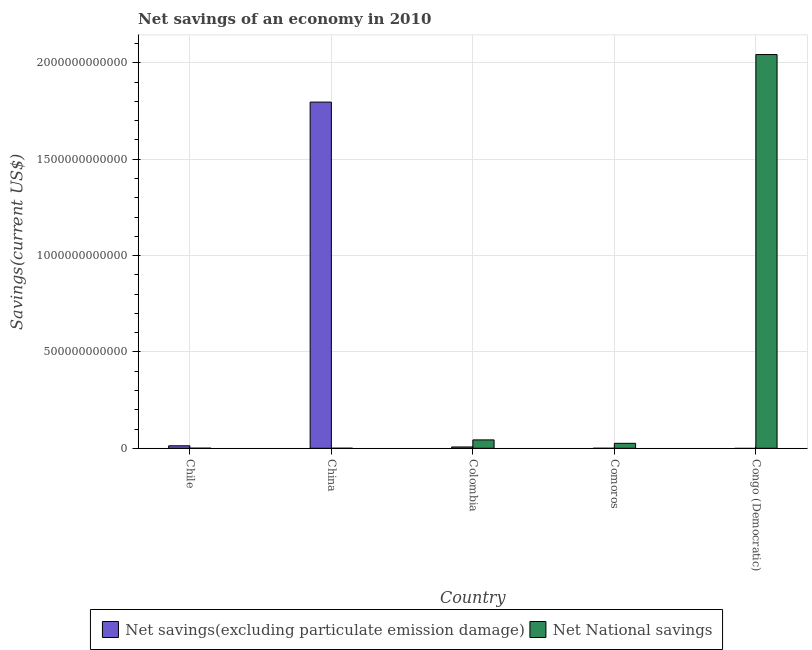How many different coloured bars are there?
Offer a terse response. 2. Are the number of bars per tick equal to the number of legend labels?
Your answer should be compact. No. Are the number of bars on each tick of the X-axis equal?
Provide a short and direct response. No. How many bars are there on the 5th tick from the left?
Your answer should be very brief. 1. How many bars are there on the 5th tick from the right?
Your answer should be very brief. 2. What is the net national savings in Colombia?
Keep it short and to the point. 4.35e+1. Across all countries, what is the maximum net savings(excluding particulate emission damage)?
Your response must be concise. 1.80e+12. Across all countries, what is the minimum net national savings?
Offer a terse response. 1.62e+08. In which country was the net savings(excluding particulate emission damage) maximum?
Your answer should be compact. China. What is the total net savings(excluding particulate emission damage) in the graph?
Your answer should be very brief. 1.82e+12. What is the difference between the net savings(excluding particulate emission damage) in Chile and that in China?
Your answer should be very brief. -1.78e+12. What is the difference between the net national savings in China and the net savings(excluding particulate emission damage) in Chile?
Provide a short and direct response. -1.27e+1. What is the average net savings(excluding particulate emission damage) per country?
Make the answer very short. 3.63e+11. What is the difference between the net national savings and net savings(excluding particulate emission damage) in Chile?
Make the answer very short. -1.26e+1. What is the ratio of the net national savings in Comoros to that in Congo (Democratic)?
Keep it short and to the point. 0.01. What is the difference between the highest and the second highest net national savings?
Make the answer very short. 2.00e+12. What is the difference between the highest and the lowest net national savings?
Provide a succinct answer. 2.04e+12. In how many countries, is the net savings(excluding particulate emission damage) greater than the average net savings(excluding particulate emission damage) taken over all countries?
Your answer should be very brief. 1. Are all the bars in the graph horizontal?
Offer a very short reply. No. How many countries are there in the graph?
Your response must be concise. 5. What is the difference between two consecutive major ticks on the Y-axis?
Give a very brief answer. 5.00e+11. Does the graph contain any zero values?
Offer a very short reply. Yes. Does the graph contain grids?
Ensure brevity in your answer.  Yes. How many legend labels are there?
Give a very brief answer. 2. How are the legend labels stacked?
Your response must be concise. Horizontal. What is the title of the graph?
Your response must be concise. Net savings of an economy in 2010. Does "Merchandise exports" appear as one of the legend labels in the graph?
Give a very brief answer. No. What is the label or title of the X-axis?
Your response must be concise. Country. What is the label or title of the Y-axis?
Your response must be concise. Savings(current US$). What is the Savings(current US$) in Net savings(excluding particulate emission damage) in Chile?
Keep it short and to the point. 1.29e+1. What is the Savings(current US$) in Net National savings in Chile?
Offer a very short reply. 3.38e+08. What is the Savings(current US$) in Net savings(excluding particulate emission damage) in China?
Offer a very short reply. 1.80e+12. What is the Savings(current US$) of Net National savings in China?
Your answer should be compact. 1.62e+08. What is the Savings(current US$) in Net savings(excluding particulate emission damage) in Colombia?
Ensure brevity in your answer.  6.82e+09. What is the Savings(current US$) in Net National savings in Colombia?
Provide a succinct answer. 4.35e+1. What is the Savings(current US$) in Net National savings in Comoros?
Your response must be concise. 2.58e+1. What is the Savings(current US$) of Net National savings in Congo (Democratic)?
Offer a very short reply. 2.04e+12. Across all countries, what is the maximum Savings(current US$) in Net savings(excluding particulate emission damage)?
Offer a very short reply. 1.80e+12. Across all countries, what is the maximum Savings(current US$) in Net National savings?
Make the answer very short. 2.04e+12. Across all countries, what is the minimum Savings(current US$) in Net savings(excluding particulate emission damage)?
Offer a terse response. 0. Across all countries, what is the minimum Savings(current US$) in Net National savings?
Give a very brief answer. 1.62e+08. What is the total Savings(current US$) in Net savings(excluding particulate emission damage) in the graph?
Keep it short and to the point. 1.82e+12. What is the total Savings(current US$) in Net National savings in the graph?
Keep it short and to the point. 2.11e+12. What is the difference between the Savings(current US$) in Net savings(excluding particulate emission damage) in Chile and that in China?
Provide a short and direct response. -1.78e+12. What is the difference between the Savings(current US$) of Net National savings in Chile and that in China?
Provide a succinct answer. 1.76e+08. What is the difference between the Savings(current US$) of Net savings(excluding particulate emission damage) in Chile and that in Colombia?
Your answer should be compact. 6.07e+09. What is the difference between the Savings(current US$) of Net National savings in Chile and that in Colombia?
Keep it short and to the point. -4.31e+1. What is the difference between the Savings(current US$) of Net National savings in Chile and that in Comoros?
Offer a terse response. -2.54e+1. What is the difference between the Savings(current US$) of Net National savings in Chile and that in Congo (Democratic)?
Provide a short and direct response. -2.04e+12. What is the difference between the Savings(current US$) in Net savings(excluding particulate emission damage) in China and that in Colombia?
Provide a succinct answer. 1.79e+12. What is the difference between the Savings(current US$) of Net National savings in China and that in Colombia?
Offer a very short reply. -4.33e+1. What is the difference between the Savings(current US$) in Net National savings in China and that in Comoros?
Keep it short and to the point. -2.56e+1. What is the difference between the Savings(current US$) in Net National savings in China and that in Congo (Democratic)?
Your answer should be compact. -2.04e+12. What is the difference between the Savings(current US$) in Net National savings in Colombia and that in Comoros?
Provide a succinct answer. 1.77e+1. What is the difference between the Savings(current US$) of Net National savings in Colombia and that in Congo (Democratic)?
Offer a very short reply. -2.00e+12. What is the difference between the Savings(current US$) in Net National savings in Comoros and that in Congo (Democratic)?
Keep it short and to the point. -2.02e+12. What is the difference between the Savings(current US$) in Net savings(excluding particulate emission damage) in Chile and the Savings(current US$) in Net National savings in China?
Give a very brief answer. 1.27e+1. What is the difference between the Savings(current US$) of Net savings(excluding particulate emission damage) in Chile and the Savings(current US$) of Net National savings in Colombia?
Offer a terse response. -3.06e+1. What is the difference between the Savings(current US$) in Net savings(excluding particulate emission damage) in Chile and the Savings(current US$) in Net National savings in Comoros?
Offer a terse response. -1.29e+1. What is the difference between the Savings(current US$) in Net savings(excluding particulate emission damage) in Chile and the Savings(current US$) in Net National savings in Congo (Democratic)?
Ensure brevity in your answer.  -2.03e+12. What is the difference between the Savings(current US$) of Net savings(excluding particulate emission damage) in China and the Savings(current US$) of Net National savings in Colombia?
Offer a very short reply. 1.75e+12. What is the difference between the Savings(current US$) of Net savings(excluding particulate emission damage) in China and the Savings(current US$) of Net National savings in Comoros?
Provide a short and direct response. 1.77e+12. What is the difference between the Savings(current US$) in Net savings(excluding particulate emission damage) in China and the Savings(current US$) in Net National savings in Congo (Democratic)?
Offer a very short reply. -2.47e+11. What is the difference between the Savings(current US$) in Net savings(excluding particulate emission damage) in Colombia and the Savings(current US$) in Net National savings in Comoros?
Your response must be concise. -1.90e+1. What is the difference between the Savings(current US$) in Net savings(excluding particulate emission damage) in Colombia and the Savings(current US$) in Net National savings in Congo (Democratic)?
Give a very brief answer. -2.04e+12. What is the average Savings(current US$) of Net savings(excluding particulate emission damage) per country?
Ensure brevity in your answer.  3.63e+11. What is the average Savings(current US$) in Net National savings per country?
Make the answer very short. 4.23e+11. What is the difference between the Savings(current US$) of Net savings(excluding particulate emission damage) and Savings(current US$) of Net National savings in Chile?
Offer a very short reply. 1.26e+1. What is the difference between the Savings(current US$) of Net savings(excluding particulate emission damage) and Savings(current US$) of Net National savings in China?
Keep it short and to the point. 1.80e+12. What is the difference between the Savings(current US$) of Net savings(excluding particulate emission damage) and Savings(current US$) of Net National savings in Colombia?
Keep it short and to the point. -3.67e+1. What is the ratio of the Savings(current US$) in Net savings(excluding particulate emission damage) in Chile to that in China?
Your answer should be very brief. 0.01. What is the ratio of the Savings(current US$) of Net National savings in Chile to that in China?
Offer a very short reply. 2.08. What is the ratio of the Savings(current US$) of Net savings(excluding particulate emission damage) in Chile to that in Colombia?
Provide a short and direct response. 1.89. What is the ratio of the Savings(current US$) in Net National savings in Chile to that in Colombia?
Offer a very short reply. 0.01. What is the ratio of the Savings(current US$) in Net National savings in Chile to that in Comoros?
Your answer should be very brief. 0.01. What is the ratio of the Savings(current US$) of Net savings(excluding particulate emission damage) in China to that in Colombia?
Offer a very short reply. 263.36. What is the ratio of the Savings(current US$) in Net National savings in China to that in Colombia?
Ensure brevity in your answer.  0. What is the ratio of the Savings(current US$) of Net National savings in China to that in Comoros?
Give a very brief answer. 0.01. What is the ratio of the Savings(current US$) in Net National savings in China to that in Congo (Democratic)?
Give a very brief answer. 0. What is the ratio of the Savings(current US$) of Net National savings in Colombia to that in Comoros?
Offer a terse response. 1.69. What is the ratio of the Savings(current US$) in Net National savings in Colombia to that in Congo (Democratic)?
Your answer should be very brief. 0.02. What is the ratio of the Savings(current US$) of Net National savings in Comoros to that in Congo (Democratic)?
Keep it short and to the point. 0.01. What is the difference between the highest and the second highest Savings(current US$) of Net savings(excluding particulate emission damage)?
Give a very brief answer. 1.78e+12. What is the difference between the highest and the second highest Savings(current US$) in Net National savings?
Give a very brief answer. 2.00e+12. What is the difference between the highest and the lowest Savings(current US$) of Net savings(excluding particulate emission damage)?
Ensure brevity in your answer.  1.80e+12. What is the difference between the highest and the lowest Savings(current US$) in Net National savings?
Make the answer very short. 2.04e+12. 